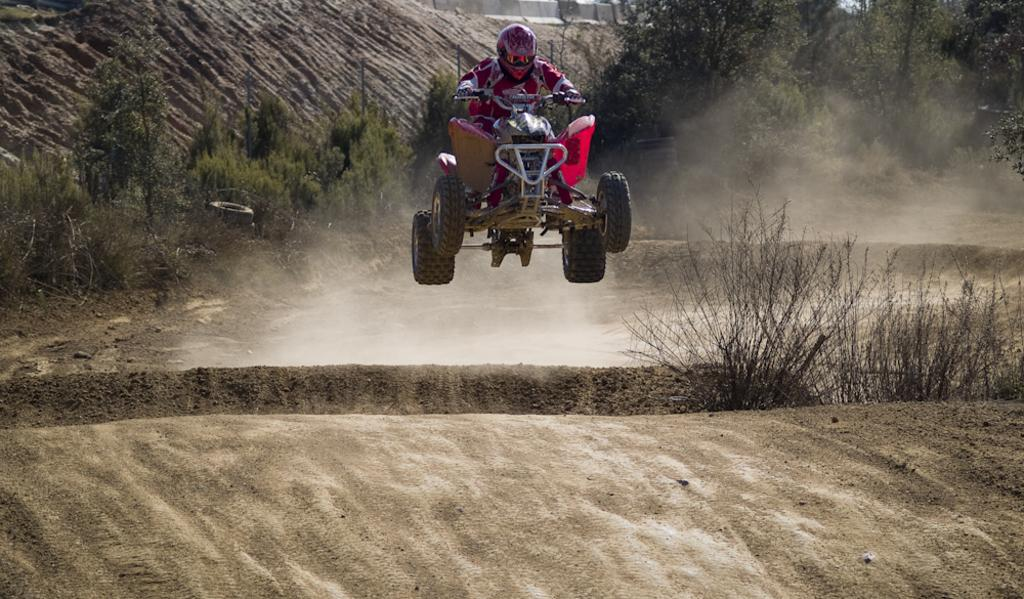What is the person in the image doing? There is a person riding a vehicle in the image. What can be seen beneath the vehicle? The ground is visible in the image. What type of vegetation is present in the image? There are plants and trees in the image. What type of bread can be seen growing on the trees in the image? There is no bread present in the image, and bread does not grow on trees. 